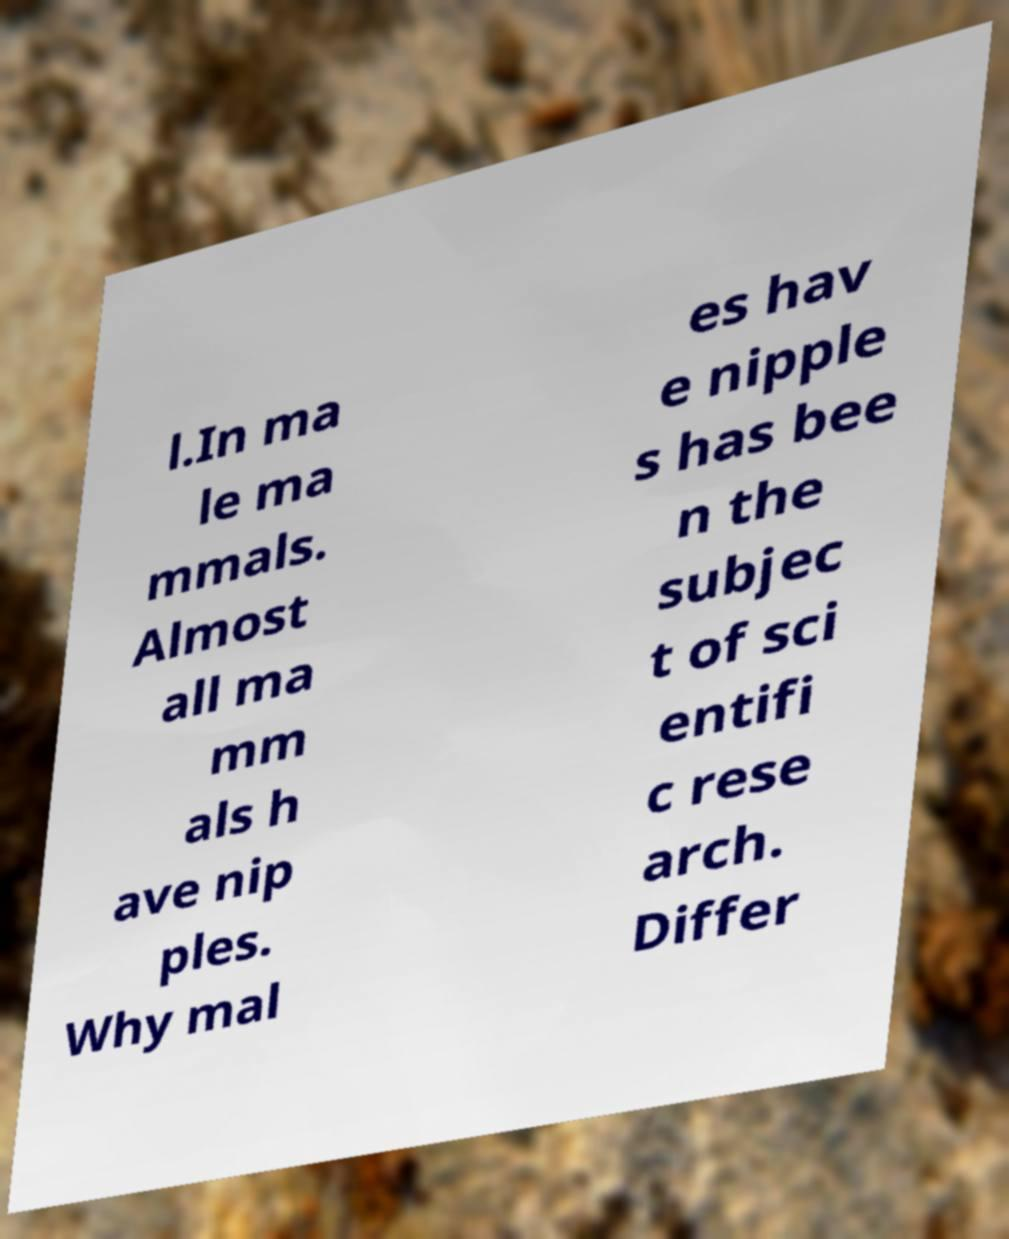Could you extract and type out the text from this image? l.In ma le ma mmals. Almost all ma mm als h ave nip ples. Why mal es hav e nipple s has bee n the subjec t of sci entifi c rese arch. Differ 